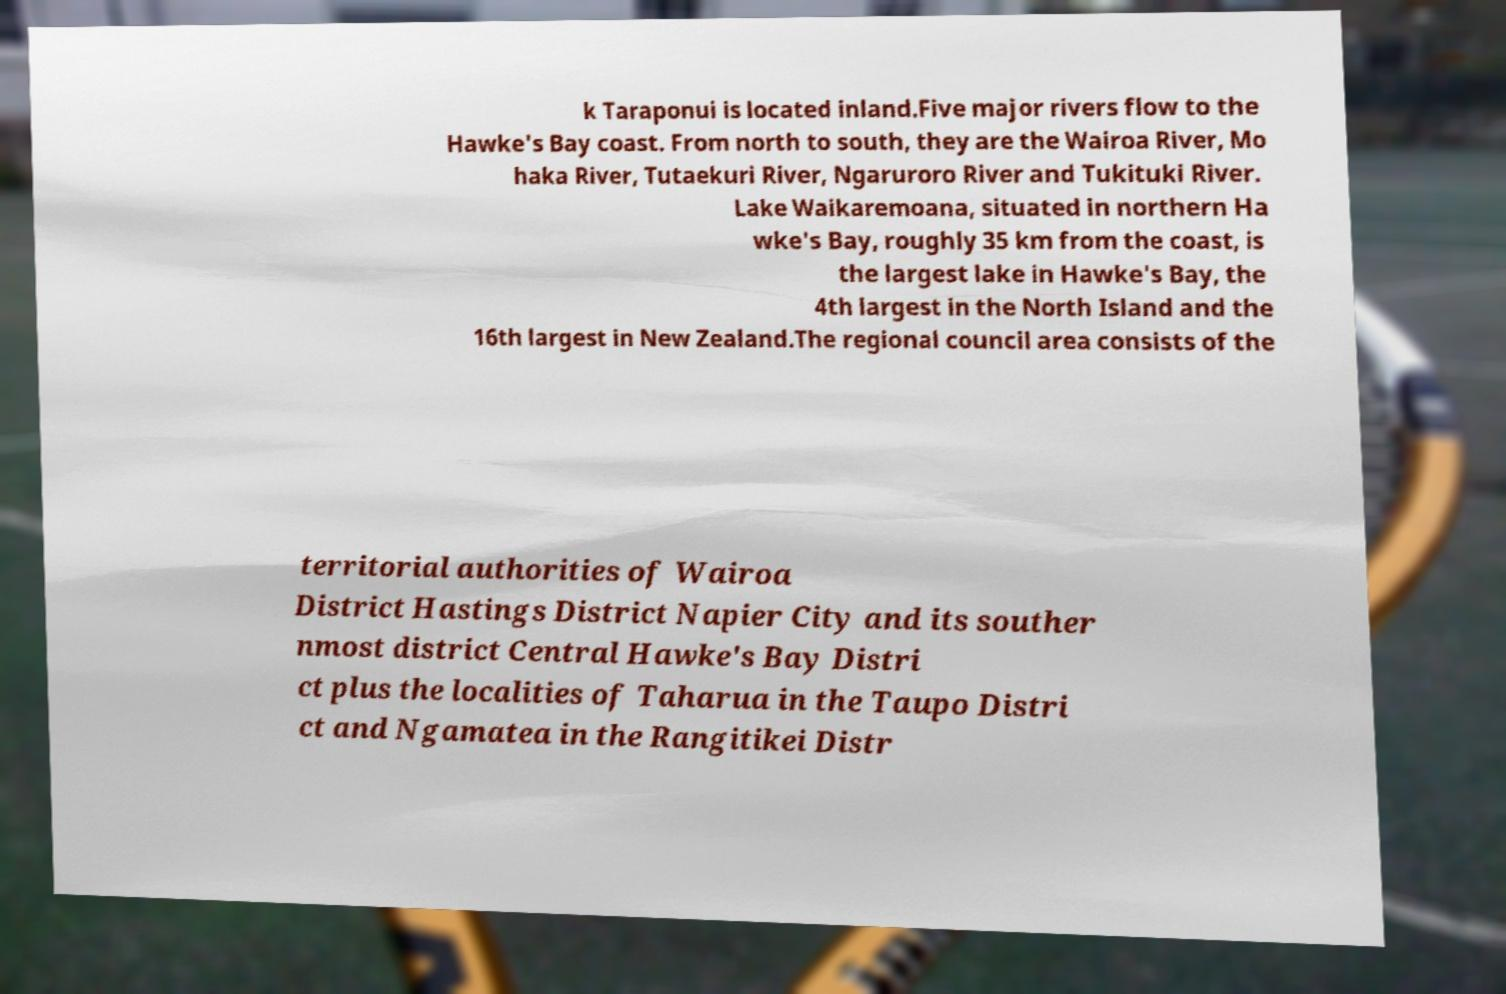Can you read and provide the text displayed in the image?This photo seems to have some interesting text. Can you extract and type it out for me? k Taraponui is located inland.Five major rivers flow to the Hawke's Bay coast. From north to south, they are the Wairoa River, Mo haka River, Tutaekuri River, Ngaruroro River and Tukituki River. Lake Waikaremoana, situated in northern Ha wke's Bay, roughly 35 km from the coast, is the largest lake in Hawke's Bay, the 4th largest in the North Island and the 16th largest in New Zealand.The regional council area consists of the territorial authorities of Wairoa District Hastings District Napier City and its souther nmost district Central Hawke's Bay Distri ct plus the localities of Taharua in the Taupo Distri ct and Ngamatea in the Rangitikei Distr 